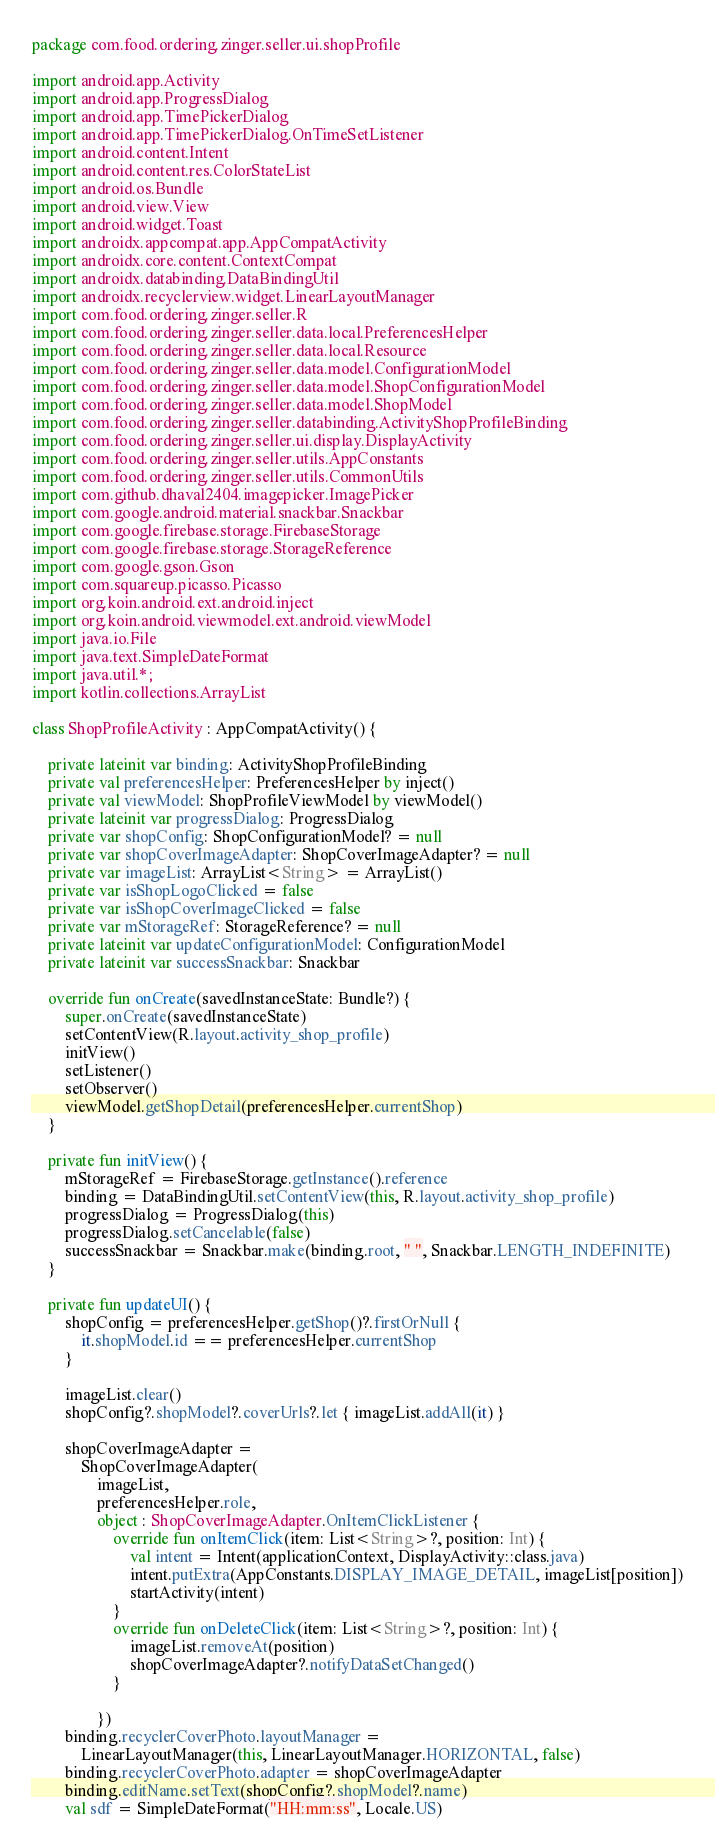<code> <loc_0><loc_0><loc_500><loc_500><_Kotlin_>package com.food.ordering.zinger.seller.ui.shopProfile

import android.app.Activity
import android.app.ProgressDialog
import android.app.TimePickerDialog
import android.app.TimePickerDialog.OnTimeSetListener
import android.content.Intent
import android.content.res.ColorStateList
import android.os.Bundle
import android.view.View
import android.widget.Toast
import androidx.appcompat.app.AppCompatActivity
import androidx.core.content.ContextCompat
import androidx.databinding.DataBindingUtil
import androidx.recyclerview.widget.LinearLayoutManager
import com.food.ordering.zinger.seller.R
import com.food.ordering.zinger.seller.data.local.PreferencesHelper
import com.food.ordering.zinger.seller.data.local.Resource
import com.food.ordering.zinger.seller.data.model.ConfigurationModel
import com.food.ordering.zinger.seller.data.model.ShopConfigurationModel
import com.food.ordering.zinger.seller.data.model.ShopModel
import com.food.ordering.zinger.seller.databinding.ActivityShopProfileBinding
import com.food.ordering.zinger.seller.ui.display.DisplayActivity
import com.food.ordering.zinger.seller.utils.AppConstants
import com.food.ordering.zinger.seller.utils.CommonUtils
import com.github.dhaval2404.imagepicker.ImagePicker
import com.google.android.material.snackbar.Snackbar
import com.google.firebase.storage.FirebaseStorage
import com.google.firebase.storage.StorageReference
import com.google.gson.Gson
import com.squareup.picasso.Picasso
import org.koin.android.ext.android.inject
import org.koin.android.viewmodel.ext.android.viewModel
import java.io.File
import java.text.SimpleDateFormat
import java.util.*;
import kotlin.collections.ArrayList

class ShopProfileActivity : AppCompatActivity() {

    private lateinit var binding: ActivityShopProfileBinding
    private val preferencesHelper: PreferencesHelper by inject()
    private val viewModel: ShopProfileViewModel by viewModel()
    private lateinit var progressDialog: ProgressDialog
    private var shopConfig: ShopConfigurationModel? = null
    private var shopCoverImageAdapter: ShopCoverImageAdapter? = null
    private var imageList: ArrayList<String> = ArrayList()
    private var isShopLogoClicked = false
    private var isShopCoverImageClicked = false
    private var mStorageRef: StorageReference? = null
    private lateinit var updateConfigurationModel: ConfigurationModel
    private lateinit var successSnackbar: Snackbar

    override fun onCreate(savedInstanceState: Bundle?) {
        super.onCreate(savedInstanceState)
        setContentView(R.layout.activity_shop_profile)
        initView()
        setListener()
        setObserver()
        viewModel.getShopDetail(preferencesHelper.currentShop)
    }

    private fun initView() {
        mStorageRef = FirebaseStorage.getInstance().reference
        binding = DataBindingUtil.setContentView(this, R.layout.activity_shop_profile)
        progressDialog = ProgressDialog(this)
        progressDialog.setCancelable(false)
        successSnackbar = Snackbar.make(binding.root, " ", Snackbar.LENGTH_INDEFINITE)
    }

    private fun updateUI() {
        shopConfig = preferencesHelper.getShop()?.firstOrNull {
            it.shopModel.id == preferencesHelper.currentShop
        }

        imageList.clear()
        shopConfig?.shopModel?.coverUrls?.let { imageList.addAll(it) }

        shopCoverImageAdapter =
            ShopCoverImageAdapter(
                imageList,
                preferencesHelper.role,
                object : ShopCoverImageAdapter.OnItemClickListener {
                    override fun onItemClick(item: List<String>?, position: Int) {
                        val intent = Intent(applicationContext, DisplayActivity::class.java)
                        intent.putExtra(AppConstants.DISPLAY_IMAGE_DETAIL, imageList[position])
                        startActivity(intent)
                    }
                    override fun onDeleteClick(item: List<String>?, position: Int) {
                        imageList.removeAt(position)
                        shopCoverImageAdapter?.notifyDataSetChanged()
                    }

                })
        binding.recyclerCoverPhoto.layoutManager =
            LinearLayoutManager(this, LinearLayoutManager.HORIZONTAL, false)
        binding.recyclerCoverPhoto.adapter = shopCoverImageAdapter
        binding.editName.setText(shopConfig?.shopModel?.name)
        val sdf = SimpleDateFormat("HH:mm:ss", Locale.US)</code> 